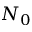<formula> <loc_0><loc_0><loc_500><loc_500>N _ { 0 }</formula> 